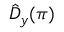Convert formula to latex. <formula><loc_0><loc_0><loc_500><loc_500>\hat { D } _ { y } ( \pi )</formula> 